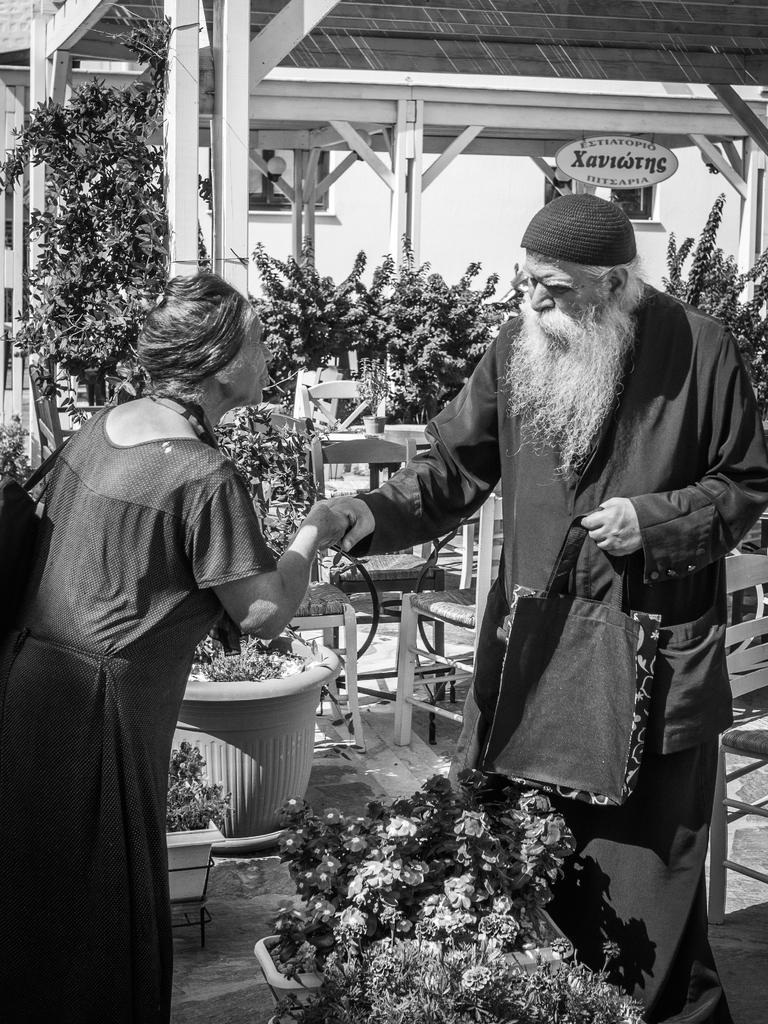How many people are in the image? There are two people in the image. What are the two people doing? The two people are standing and shaking hands. What can be seen at the bottom of the image? There are plants at the bottom of the image. What objects are visible in the background of the image? There are chairs and sheds in the background of the image. What type of winter clothing is the monkey wearing in the image? There is no monkey present in the image, and therefore no winter clothing can be observed. 